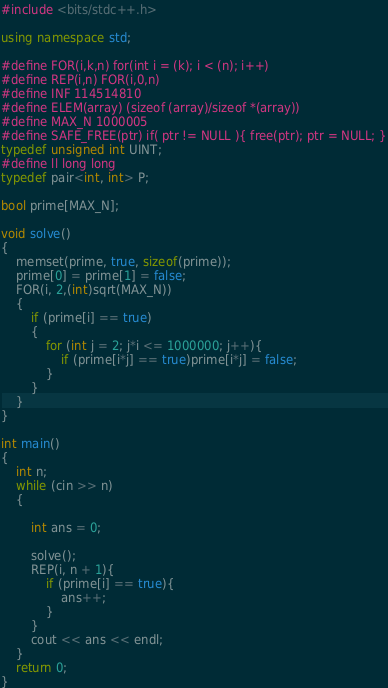<code> <loc_0><loc_0><loc_500><loc_500><_C++_>#include <bits/stdc++.h>

using namespace std;

#define FOR(i,k,n) for(int i = (k); i < (n); i++)
#define REP(i,n) FOR(i,0,n)
#define INF 114514810
#define ELEM(array) (sizeof (array)/sizeof *(array))
#define MAX_N 1000005
#define SAFE_FREE(ptr) if( ptr != NULL ){ free(ptr); ptr = NULL; }
typedef unsigned int UINT;
#define ll long long
typedef pair<int, int> P;

bool prime[MAX_N];

void solve()
{
	memset(prime, true, sizeof(prime));
	prime[0] = prime[1] = false;
	FOR(i, 2,(int)sqrt(MAX_N))
	{
		if (prime[i] == true)
		{
			for (int j = 2; j*i <= 1000000; j++){
				if (prime[i*j] == true)prime[i*j] = false;
			}
		}
	}
}

int main()
{
	int n;
	while (cin >> n)
	{

		int ans = 0;

		solve();
		REP(i, n + 1){
			if (prime[i] == true){
				ans++;
			}
		}
		cout << ans << endl;
	}
	return 0;
}</code> 